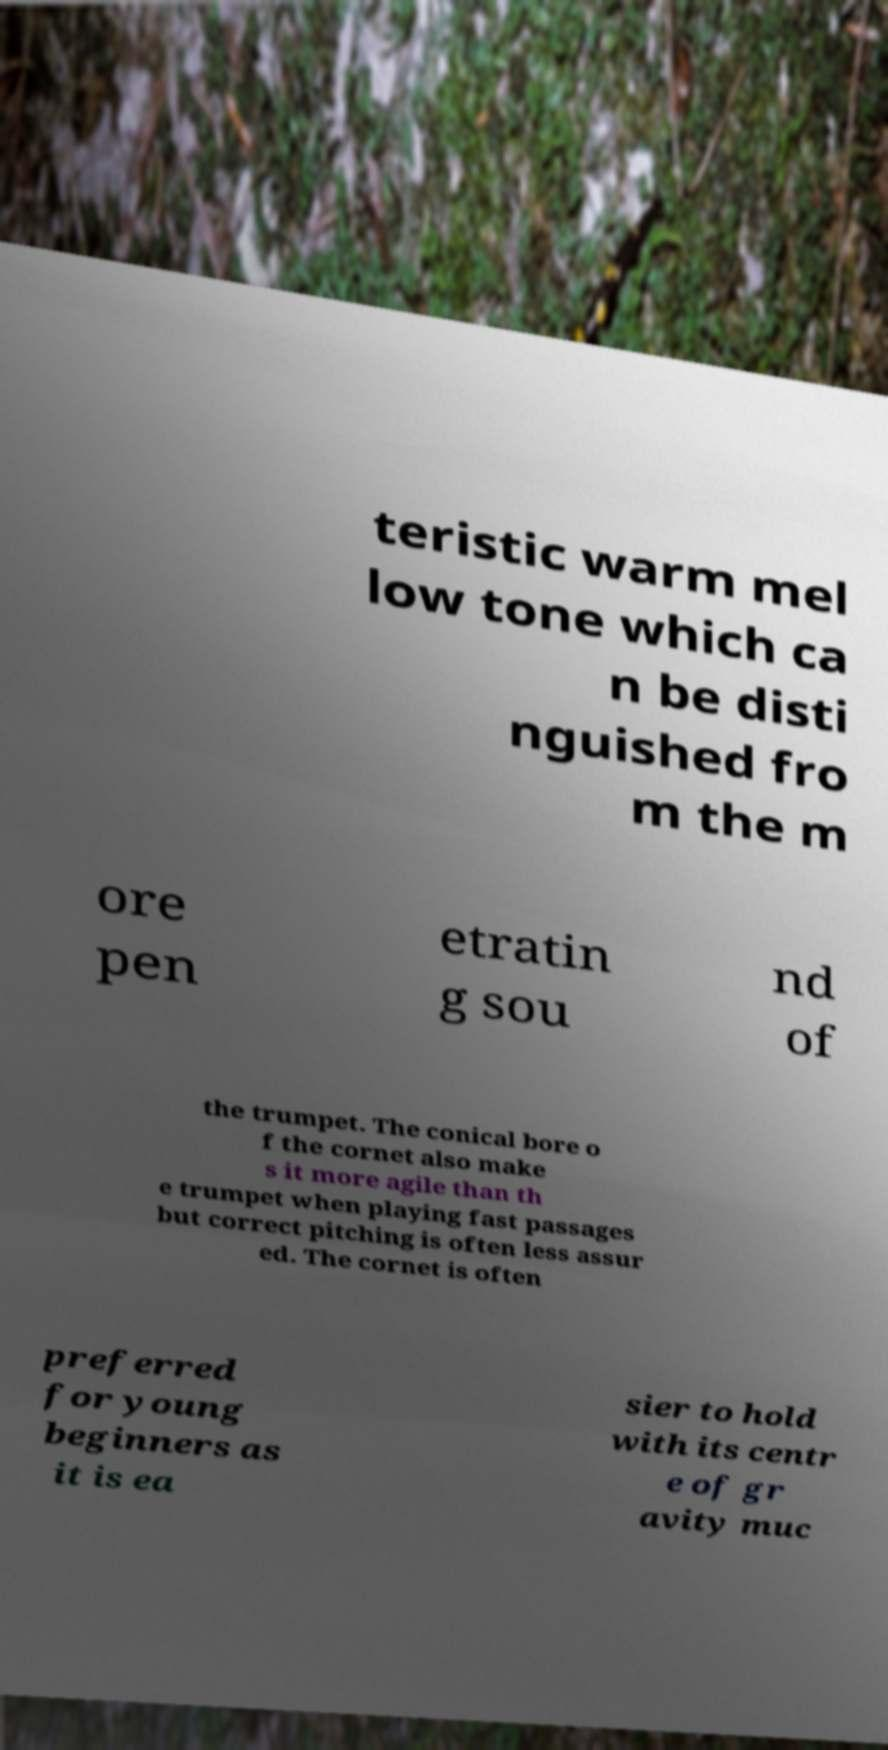Could you extract and type out the text from this image? teristic warm mel low tone which ca n be disti nguished fro m the m ore pen etratin g sou nd of the trumpet. The conical bore o f the cornet also make s it more agile than th e trumpet when playing fast passages but correct pitching is often less assur ed. The cornet is often preferred for young beginners as it is ea sier to hold with its centr e of gr avity muc 